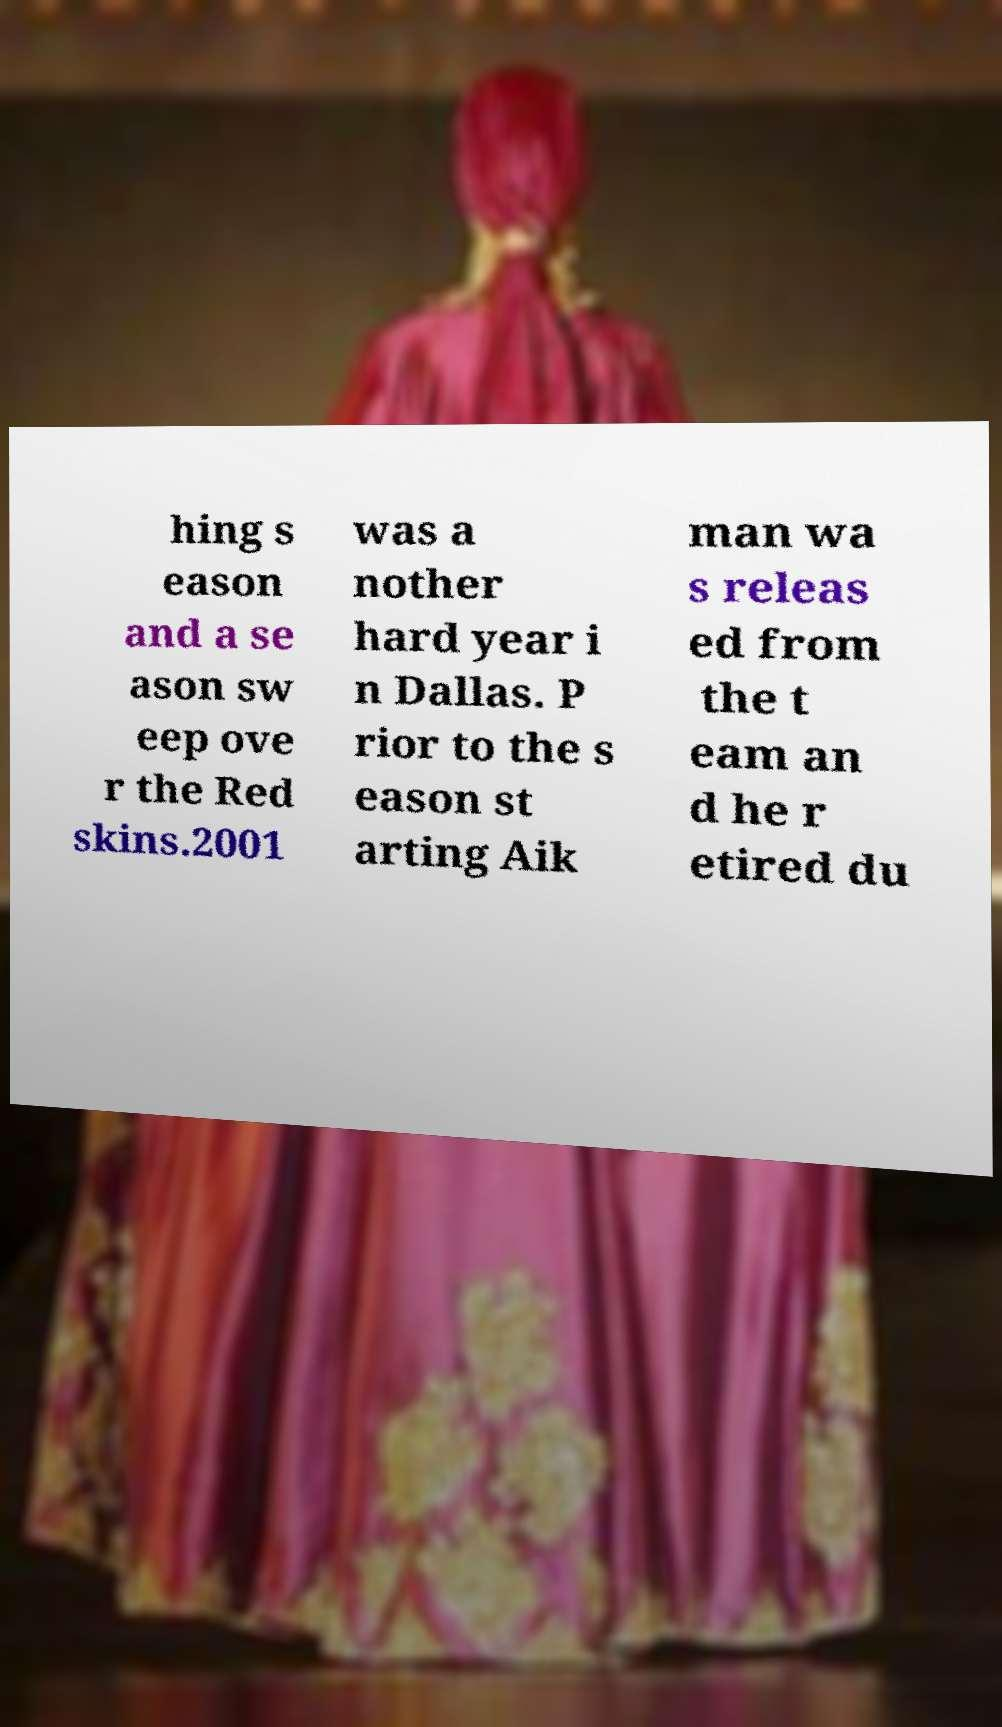What messages or text are displayed in this image? I need them in a readable, typed format. hing s eason and a se ason sw eep ove r the Red skins.2001 was a nother hard year i n Dallas. P rior to the s eason st arting Aik man wa s releas ed from the t eam an d he r etired du 